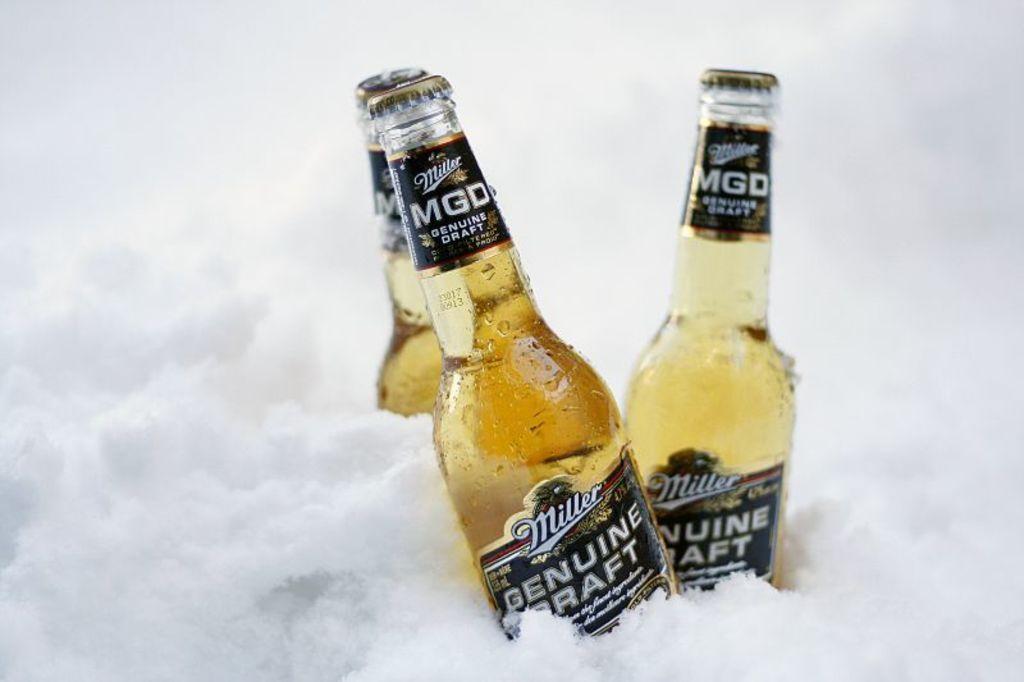How would you summarize this image in a sentence or two? This 3 bottles are inside a ice. 